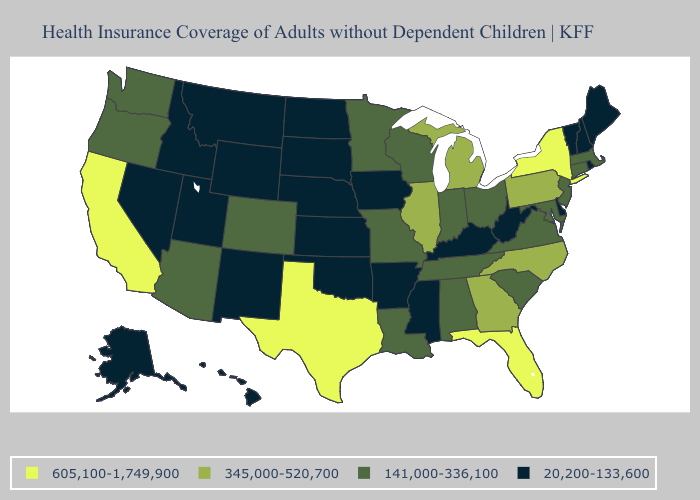What is the value of Michigan?
Quick response, please. 345,000-520,700. Does Missouri have the lowest value in the USA?
Be succinct. No. What is the highest value in the West ?
Give a very brief answer. 605,100-1,749,900. Among the states that border California , which have the lowest value?
Write a very short answer. Nevada. How many symbols are there in the legend?
Write a very short answer. 4. Which states have the lowest value in the USA?
Be succinct. Alaska, Arkansas, Delaware, Hawaii, Idaho, Iowa, Kansas, Kentucky, Maine, Mississippi, Montana, Nebraska, Nevada, New Hampshire, New Mexico, North Dakota, Oklahoma, Rhode Island, South Dakota, Utah, Vermont, West Virginia, Wyoming. What is the lowest value in the South?
Quick response, please. 20,200-133,600. What is the value of Utah?
Give a very brief answer. 20,200-133,600. How many symbols are there in the legend?
Be succinct. 4. What is the lowest value in the USA?
Give a very brief answer. 20,200-133,600. Among the states that border Arizona , does California have the lowest value?
Quick response, please. No. What is the value of Virginia?
Concise answer only. 141,000-336,100. What is the value of Tennessee?
Concise answer only. 141,000-336,100. Name the states that have a value in the range 20,200-133,600?
Write a very short answer. Alaska, Arkansas, Delaware, Hawaii, Idaho, Iowa, Kansas, Kentucky, Maine, Mississippi, Montana, Nebraska, Nevada, New Hampshire, New Mexico, North Dakota, Oklahoma, Rhode Island, South Dakota, Utah, Vermont, West Virginia, Wyoming. Name the states that have a value in the range 141,000-336,100?
Write a very short answer. Alabama, Arizona, Colorado, Connecticut, Indiana, Louisiana, Maryland, Massachusetts, Minnesota, Missouri, New Jersey, Ohio, Oregon, South Carolina, Tennessee, Virginia, Washington, Wisconsin. 